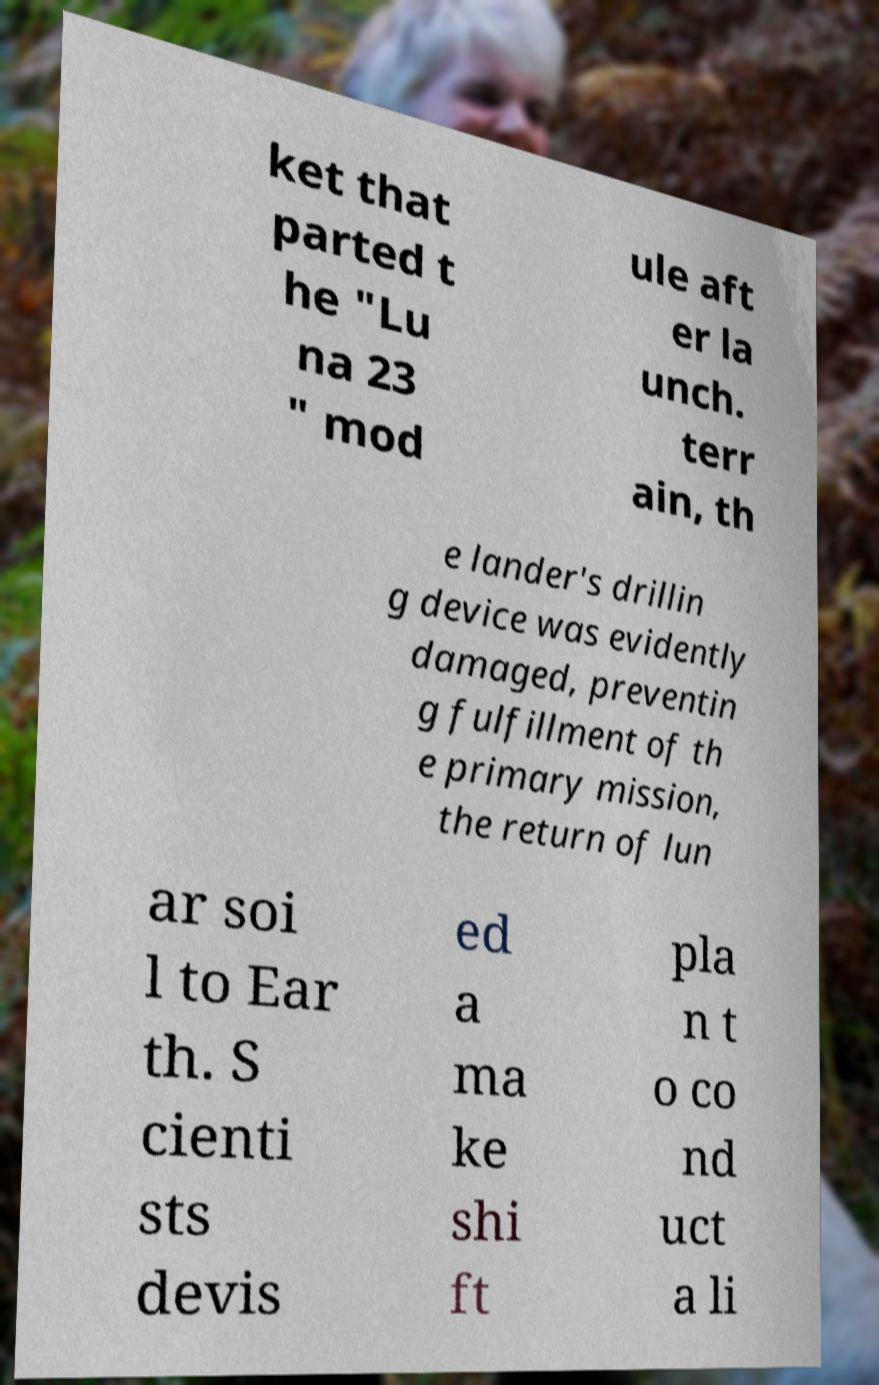Can you accurately transcribe the text from the provided image for me? ket that parted t he "Lu na 23 " mod ule aft er la unch. terr ain, th e lander's drillin g device was evidently damaged, preventin g fulfillment of th e primary mission, the return of lun ar soi l to Ear th. S cienti sts devis ed a ma ke shi ft pla n t o co nd uct a li 